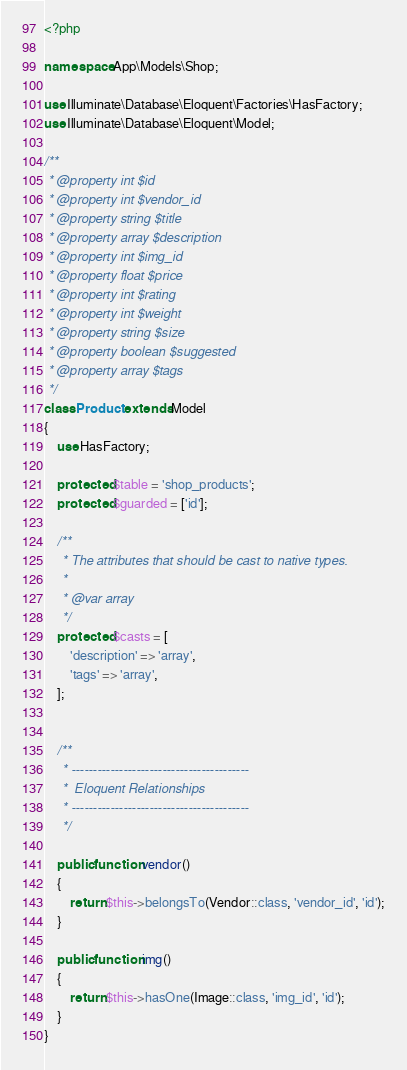<code> <loc_0><loc_0><loc_500><loc_500><_PHP_><?php

namespace App\Models\Shop;

use Illuminate\Database\Eloquent\Factories\HasFactory;
use Illuminate\Database\Eloquent\Model;

/**
 * @property int $id
 * @property int $vendor_id
 * @property string $title
 * @property array $description
 * @property int $img_id
 * @property float $price
 * @property int $rating
 * @property int $weight
 * @property string $size
 * @property boolean $suggested
 * @property array $tags
 */
class Product extends Model
{
	use HasFactory;

	protected $table = 'shop_products';
	protected $guarded = ['id'];

	/**
	 * The attributes that should be cast to native types.
	 *
	 * @var array
	 */
	protected $casts = [
		'description' => 'array',
		'tags' => 'array',
	];


	/**
	 * -----------------------------------------
	 *	Eloquent Relationships
	 * -----------------------------------------
	 */

	public function vendor()
	{
		return $this->belongsTo(Vendor::class, 'vendor_id', 'id');
	}

	public function img()
	{
		return $this->hasOne(Image::class, 'img_id', 'id');
	}
}
</code> 